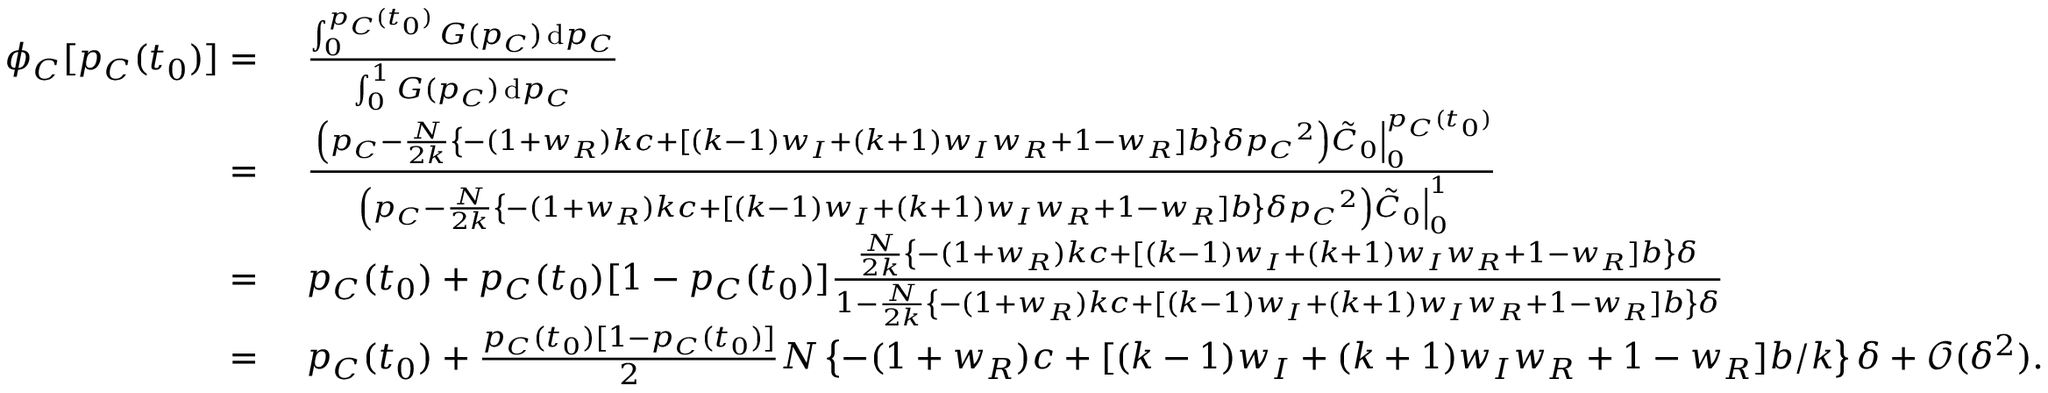Convert formula to latex. <formula><loc_0><loc_0><loc_500><loc_500>\begin{array} { r l } { \phi _ { C } [ p _ { C } ( t _ { 0 } ) ] = } & { \frac { \int _ { 0 } ^ { p _ { C } ( t _ { 0 } ) } { G ( p _ { C } ) } \, d p _ { C } } { \int _ { 0 } ^ { 1 } { G ( p _ { C } ) } \, d p _ { C } } } \\ { = } & { \frac { \left ( p _ { C } - \frac { N } { 2 k } \left \{ - ( 1 + w _ { R } ) k c + [ ( k - 1 ) w _ { I } + ( k + 1 ) w _ { I } w _ { R } + 1 - w _ { R } ] b \right \} \delta { p _ { C } } ^ { 2 } \right ) \tilde { C } _ { 0 } \right | _ { 0 } ^ { p _ { C } ( t _ { 0 } ) } } { \left ( p _ { C } - \frac { N } { 2 k } \left \{ - ( 1 + w _ { R } ) k c + [ ( k - 1 ) w _ { I } + ( k + 1 ) w _ { I } w _ { R } + 1 - w _ { R } ] b \right \} \delta { p _ { C } } ^ { 2 } \right ) \tilde { C } _ { 0 } \right | _ { 0 } ^ { 1 } } } \\ { = } & { p _ { C } ( t _ { 0 } ) + p _ { C } ( t _ { 0 } ) [ 1 - p _ { C } ( t _ { 0 } ) ] \frac { \frac { N } { 2 k } \left \{ - ( 1 + w _ { R } ) k c + [ ( k - 1 ) w _ { I } + ( k + 1 ) w _ { I } w _ { R } + 1 - w _ { R } ] b \right \} \delta } { 1 - \frac { N } { 2 k } \left \{ - ( 1 + w _ { R } ) k c + [ ( k - 1 ) w _ { I } + ( k + 1 ) w _ { I } w _ { R } + 1 - w _ { R } ] b \right \} \delta } } \\ { = } & { p _ { C } ( t _ { 0 } ) + \frac { p _ { C } ( t _ { 0 } ) [ 1 - p _ { C } ( t _ { 0 } ) ] } { 2 } N \left \{ - ( 1 + w _ { R } ) c + [ ( k - 1 ) w _ { I } + ( k + 1 ) w _ { I } w _ { R } + 1 - w _ { R } ] b / k \right \} \delta + \mathcal { O } ( \delta ^ { 2 } ) . } \end{array}</formula> 